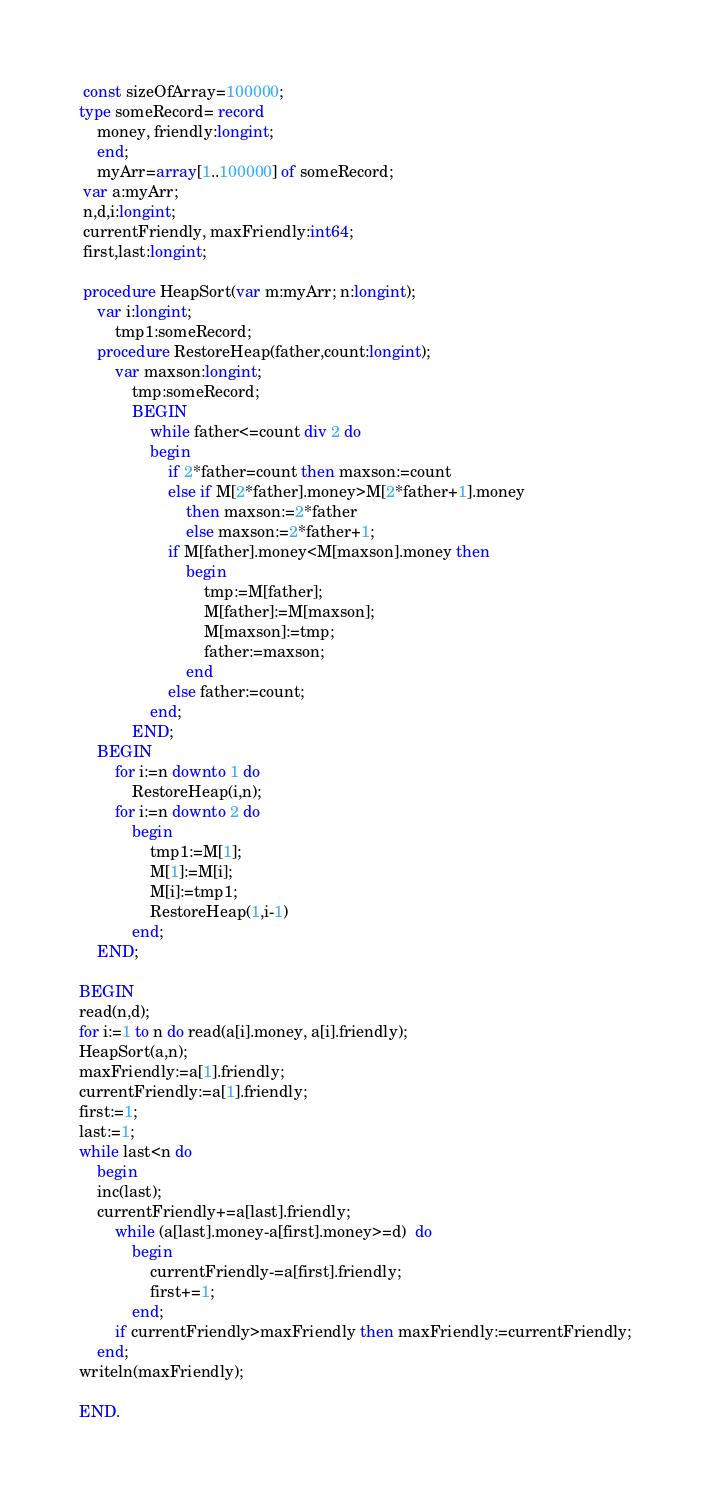Convert code to text. <code><loc_0><loc_0><loc_500><loc_500><_Pascal_> const sizeOfArray=100000;
type someRecord= record
	money, friendly:longint;
	end;
	myArr=array[1..100000] of someRecord;
 var a:myArr;
 n,d,i:longint;
 currentFriendly, maxFriendly:int64;
 first,last:longint;
 
 procedure HeapSort(var m:myArr; n:longint);
	var i:longint;
		tmp1:someRecord;
	procedure RestoreHeap(father,count:longint);
		var maxson:longint;
			tmp:someRecord;
			BEGIN
				while father<=count div 2 do	
				begin
					if 2*father=count then maxson:=count
					else if M[2*father].money>M[2*father+1].money
						then maxson:=2*father
						else maxson:=2*father+1;
					if M[father].money<M[maxson].money then	
						begin
							tmp:=M[father];
							M[father]:=M[maxson];
							M[maxson]:=tmp;
							father:=maxson;
						end
					else father:=count;
				end;
			END;
	BEGIN
		for i:=n downto 1 do
			RestoreHeap(i,n);
		for i:=n downto 2 do
			begin
				tmp1:=M[1];
				M[1]:=M[i];
				M[i]:=tmp1;
				RestoreHeap(1,i-1)
			end;
	END;

BEGIN
read(n,d);
for i:=1 to n do read(a[i].money, a[i].friendly);
HeapSort(a,n);
maxFriendly:=a[1].friendly;
currentFriendly:=a[1].friendly;
first:=1;
last:=1;
while last<n do	
	begin
	inc(last);
	currentFriendly+=a[last].friendly;
		while (a[last].money-a[first].money>=d)  do
			begin
				currentFriendly-=a[first].friendly;
				first+=1;
			end;
		if currentFriendly>maxFriendly then maxFriendly:=currentFriendly;
	end;
writeln(maxFriendly);

END.</code> 